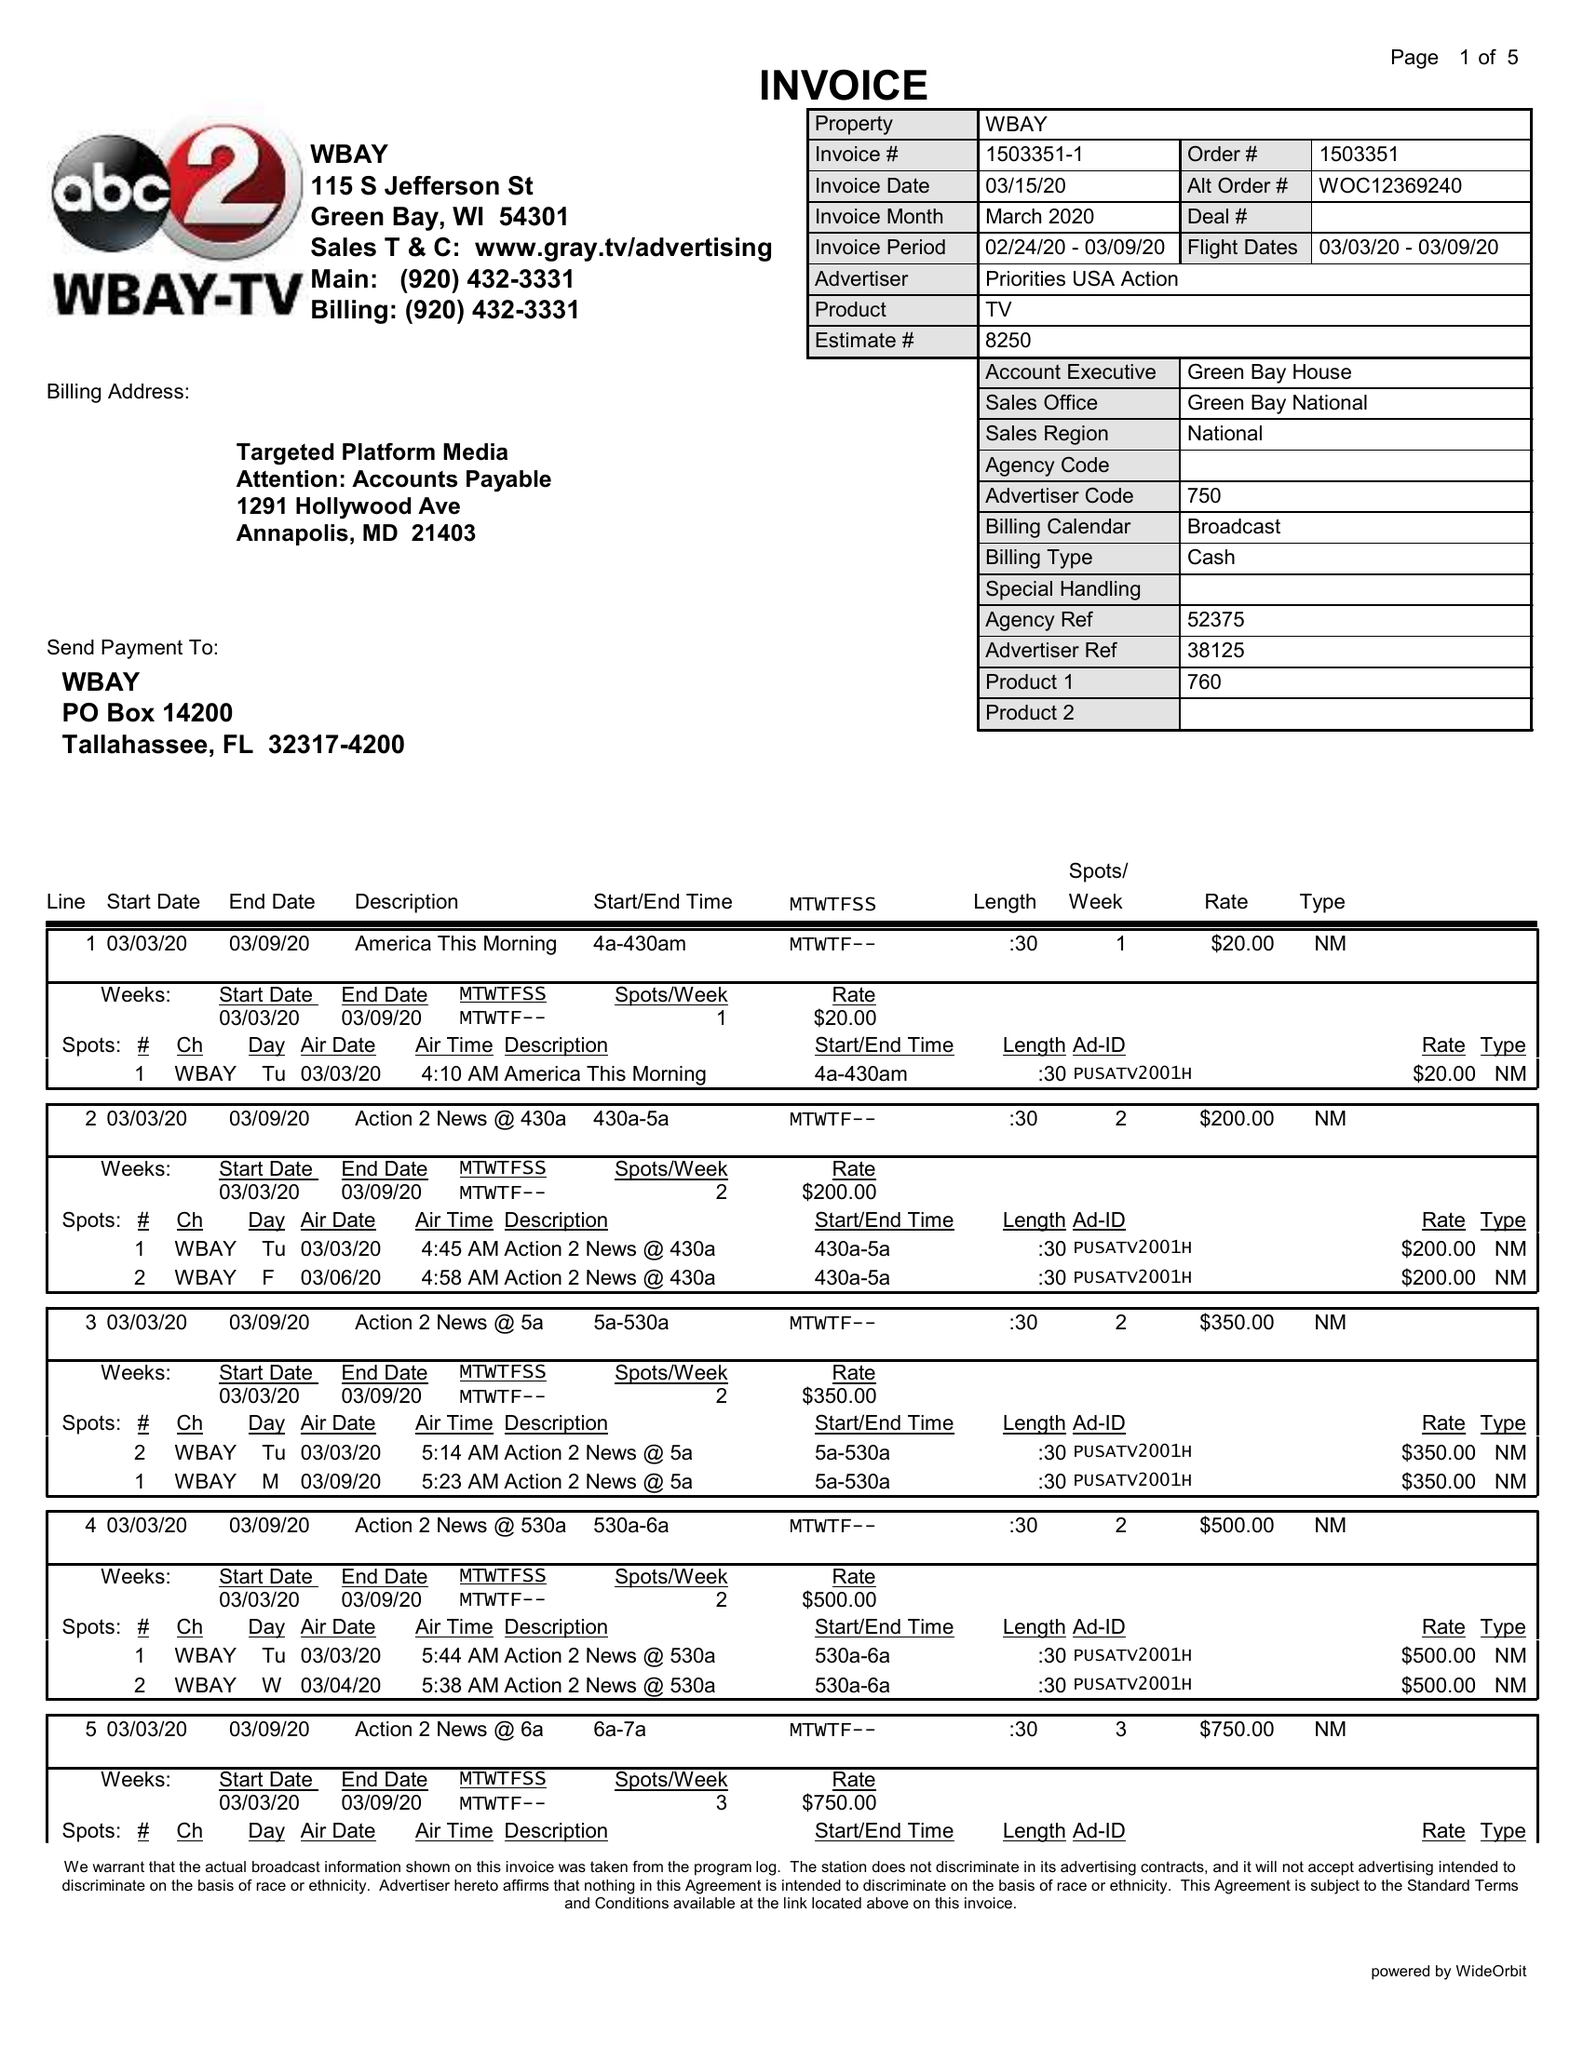What is the value for the advertiser?
Answer the question using a single word or phrase. PRIORITIES USA ACTION 